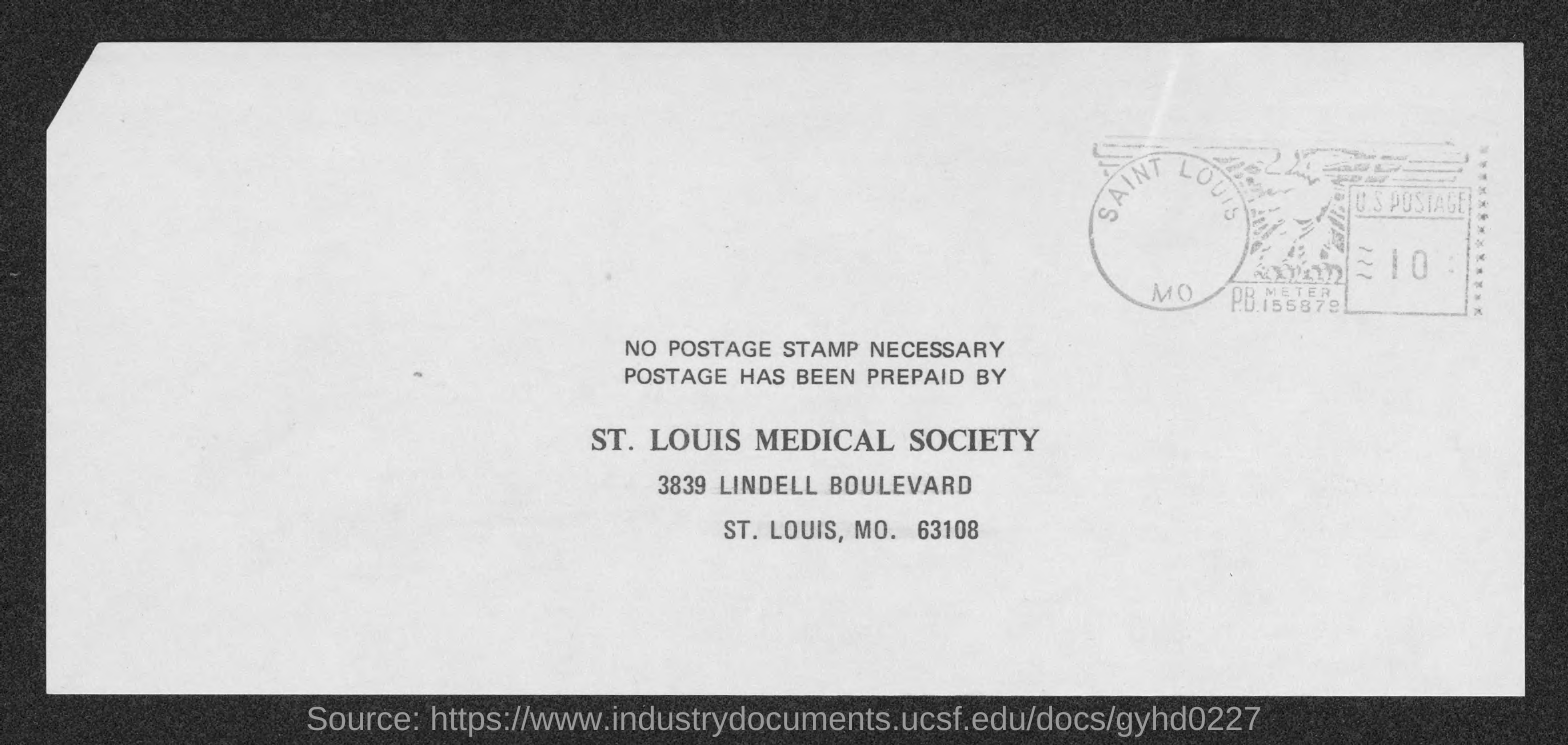Identify some key points in this picture. The St. Louis Medical Society has prepaid the postage. The zip code is 63108. 